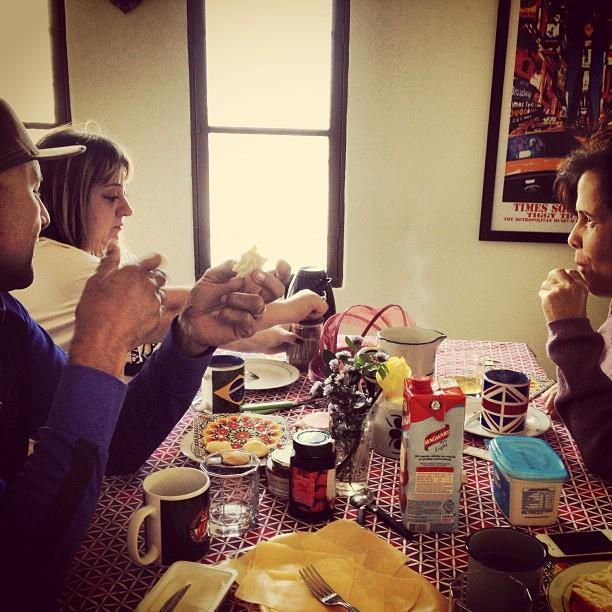Why have these people gathered?
From the following four choices, select the correct answer to address the question.
Options: To compete, to eat, to play, to work. To eat. 